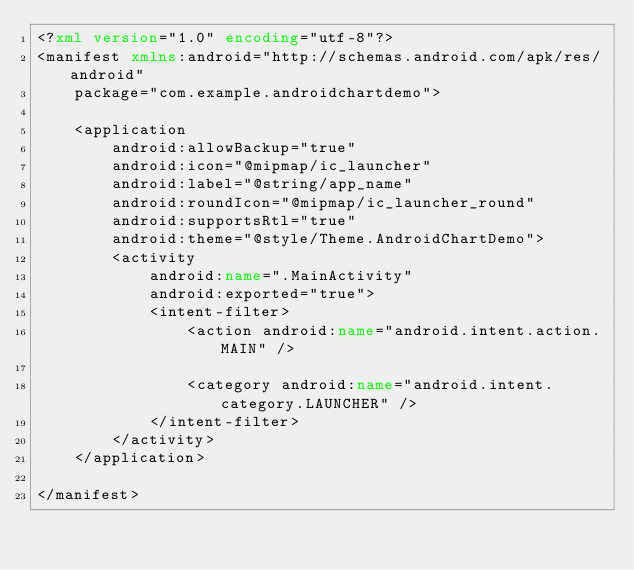<code> <loc_0><loc_0><loc_500><loc_500><_XML_><?xml version="1.0" encoding="utf-8"?>
<manifest xmlns:android="http://schemas.android.com/apk/res/android"
    package="com.example.androidchartdemo">

    <application
        android:allowBackup="true"
        android:icon="@mipmap/ic_launcher"
        android:label="@string/app_name"
        android:roundIcon="@mipmap/ic_launcher_round"
        android:supportsRtl="true"
        android:theme="@style/Theme.AndroidChartDemo">
        <activity
            android:name=".MainActivity"
            android:exported="true">
            <intent-filter>
                <action android:name="android.intent.action.MAIN" />

                <category android:name="android.intent.category.LAUNCHER" />
            </intent-filter>
        </activity>
    </application>

</manifest></code> 